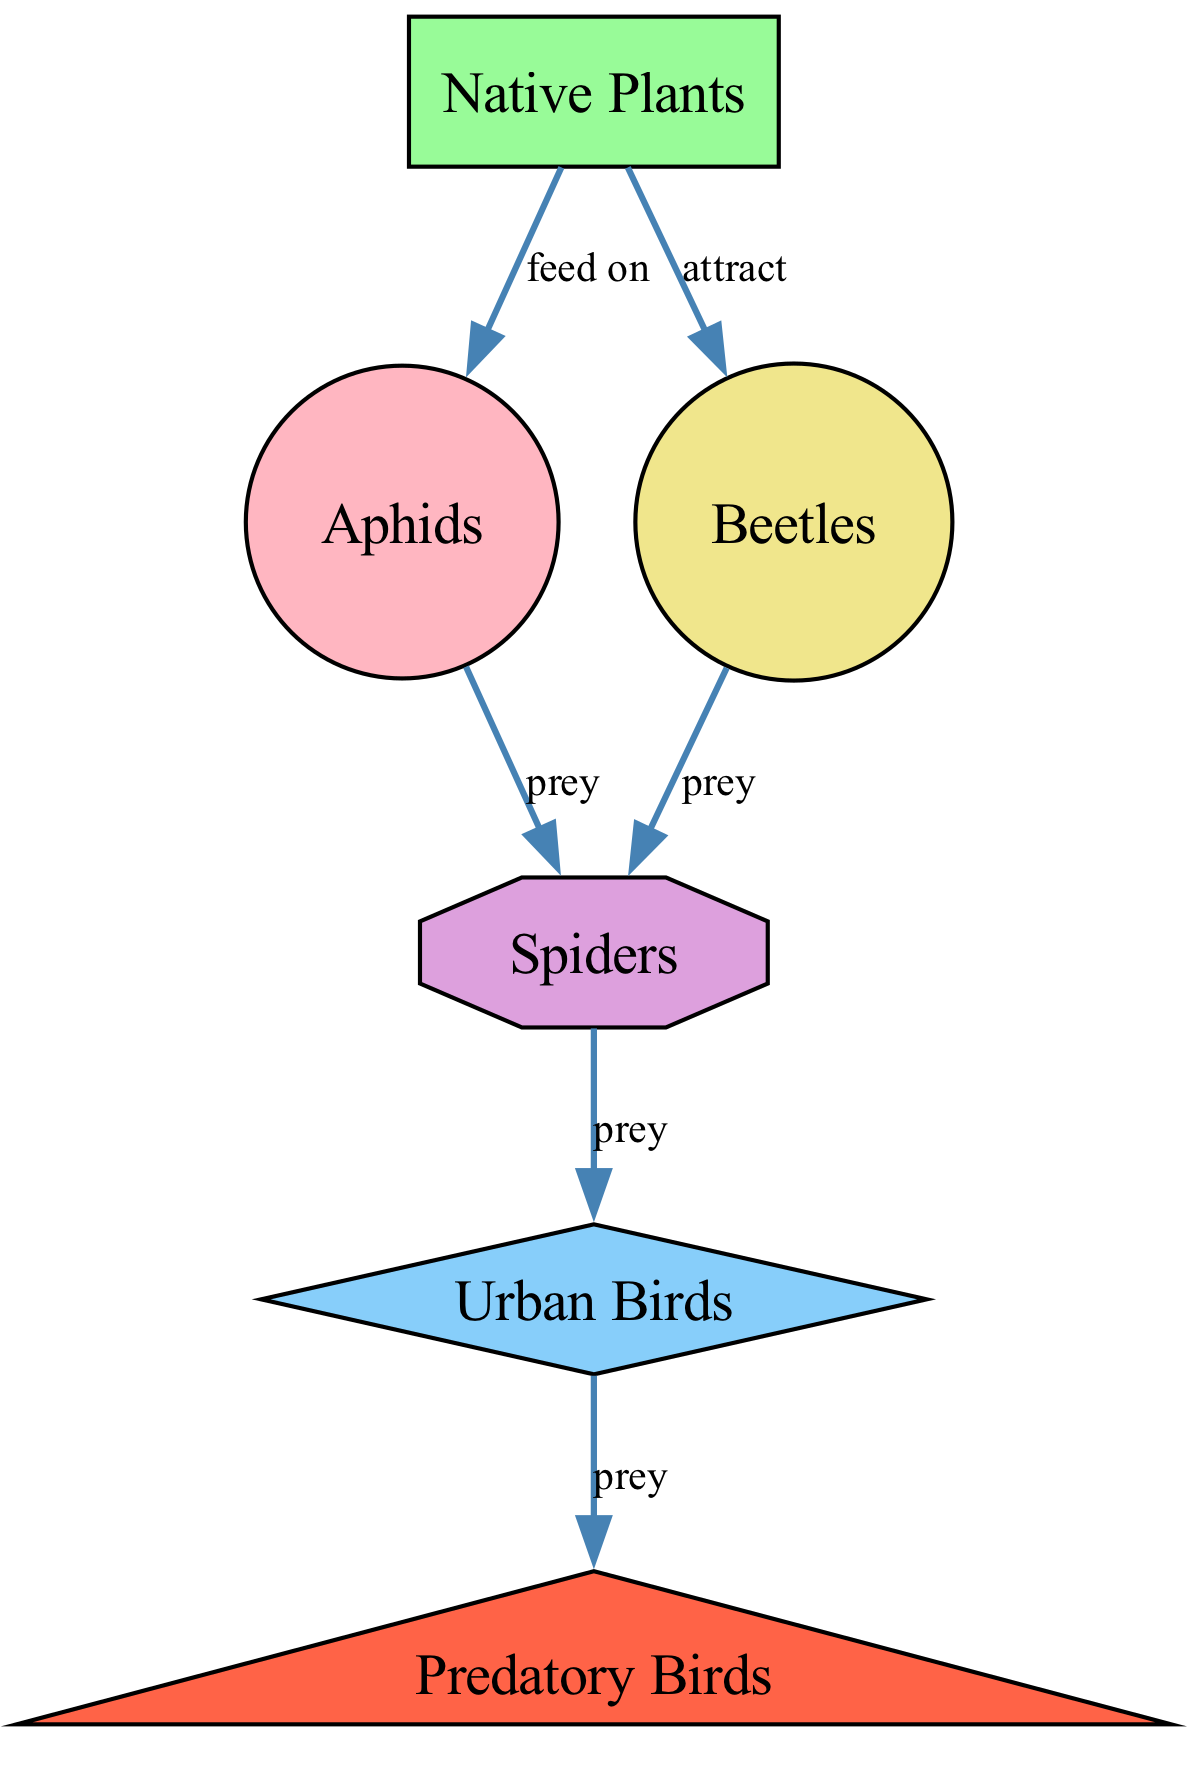What is the total number of nodes in the diagram? The diagram lists six distinct entities: Native Plants, Aphids, Beetles, Spiders, Urban Birds, and Predatory Birds. Counting these gives a total of six nodes.
Answer: 6 Which node is prey to Spiders? The diagram indicates that both Aphids and Beetles have arrows pointing towards Spiders, meaning they are both considered prey to Spiders.
Answer: Aphids and Beetles What type of relationship exists between Plants and Beetles? The edge between Plants and Beetles is labeled “attract,” indicating a non-predatory relationship where Plants draw Beetles towards them, not as prey but as a beneficial connection.
Answer: attract How many organisms directly prey on Spiders? According to the diagram, the Urban Birds are the only organisms that prey on Spiders, as indicated by a single arrow pointing from Birds to Spiders. Thus, there is one organism that preys on Spiders.
Answer: 1 What is the flow of energy from Native Plants to Predatory Birds? Energy begins at Native Plants, where Aphids and Beetles are attracted. Aphids and Beetles then serve as prey for Spiders. Spiders are then preyed upon by Urban Birds, which are further preyed upon by Predatory Birds. Thus, the flow of energy follows this pathway: Plants → Aphids/Beetles → Spiders → Birds → Predators.
Answer: Plants → Aphids/Beetles → Spiders → Birds → Predators Which group of organisms is the top predator in this food chain? The diagram shows an arrow pointing from Urban Birds to Predatory Birds, indicating that Predatory Birds prey on Urban Birds. Therefore, Predatory Birds are the top predators in this food chain.
Answer: Predatory Birds What is the relationship type between Birds and Predators? The relationship indicated between Birds and Predators is labeled “prey,” which shows that Predatory Birds consume Urban Birds. This signifies a direct predator-prey relationship.
Answer: prey How many direct edges are there in the diagram? The diagram consists of five connections (edges): Plants to Aphids, Plants to Beetles, Aphids to Spiders, Beetles to Spiders, Spiders to Birds, and Birds to Predators. This totals to six edges.
Answer: 6 Which category of organisms is at the primary producer level? The diagram shows that Native Plants are the starting point of the food chain, where energy production occurs through photosynthesis. Hence, Native Plants serve as the primary producers.
Answer: Native Plants 